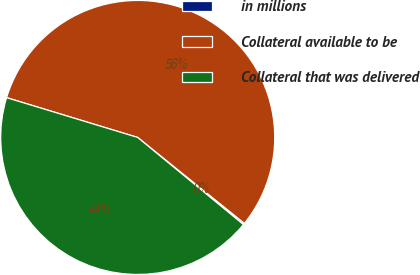<chart> <loc_0><loc_0><loc_500><loc_500><pie_chart><fcel>in millions<fcel>Collateral available to be<fcel>Collateral that was delivered<nl><fcel>0.18%<fcel>56.1%<fcel>43.72%<nl></chart> 